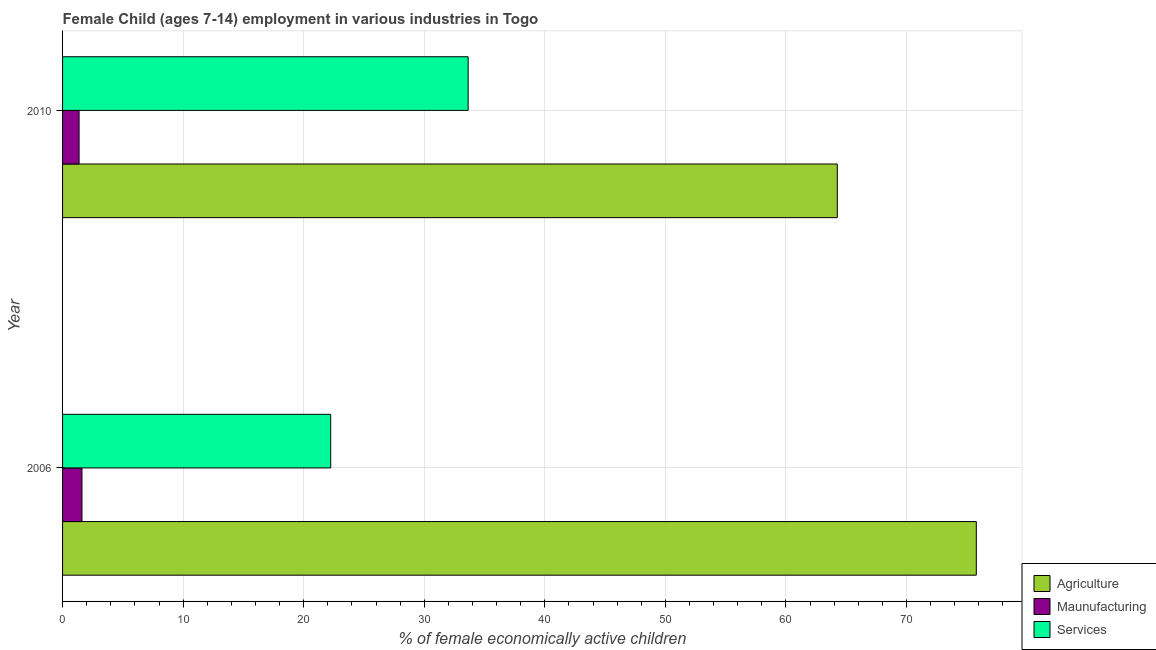How many groups of bars are there?
Keep it short and to the point. 2. How many bars are there on the 2nd tick from the top?
Make the answer very short. 3. What is the percentage of economically active children in services in 2010?
Make the answer very short. 33.64. Across all years, what is the maximum percentage of economically active children in agriculture?
Make the answer very short. 75.79. Across all years, what is the minimum percentage of economically active children in manufacturing?
Keep it short and to the point. 1.37. In which year was the percentage of economically active children in agriculture maximum?
Keep it short and to the point. 2006. In which year was the percentage of economically active children in agriculture minimum?
Make the answer very short. 2010. What is the total percentage of economically active children in services in the graph?
Offer a terse response. 55.88. What is the difference between the percentage of economically active children in services in 2006 and that in 2010?
Your response must be concise. -11.4. What is the difference between the percentage of economically active children in agriculture in 2006 and the percentage of economically active children in manufacturing in 2010?
Make the answer very short. 74.42. What is the average percentage of economically active children in services per year?
Offer a terse response. 27.94. In the year 2010, what is the difference between the percentage of economically active children in services and percentage of economically active children in agriculture?
Keep it short and to the point. -30.62. What is the ratio of the percentage of economically active children in services in 2006 to that in 2010?
Offer a very short reply. 0.66. Is the percentage of economically active children in services in 2006 less than that in 2010?
Offer a very short reply. Yes. In how many years, is the percentage of economically active children in agriculture greater than the average percentage of economically active children in agriculture taken over all years?
Keep it short and to the point. 1. What does the 1st bar from the top in 2006 represents?
Give a very brief answer. Services. What does the 2nd bar from the bottom in 2010 represents?
Give a very brief answer. Maunufacturing. Is it the case that in every year, the sum of the percentage of economically active children in agriculture and percentage of economically active children in manufacturing is greater than the percentage of economically active children in services?
Give a very brief answer. Yes. How many years are there in the graph?
Make the answer very short. 2. What is the difference between two consecutive major ticks on the X-axis?
Offer a terse response. 10. Are the values on the major ticks of X-axis written in scientific E-notation?
Make the answer very short. No. Does the graph contain any zero values?
Your answer should be very brief. No. Does the graph contain grids?
Provide a succinct answer. Yes. What is the title of the graph?
Keep it short and to the point. Female Child (ages 7-14) employment in various industries in Togo. What is the label or title of the X-axis?
Make the answer very short. % of female economically active children. What is the label or title of the Y-axis?
Your answer should be compact. Year. What is the % of female economically active children in Agriculture in 2006?
Provide a succinct answer. 75.79. What is the % of female economically active children in Maunufacturing in 2006?
Provide a succinct answer. 1.61. What is the % of female economically active children in Services in 2006?
Provide a short and direct response. 22.24. What is the % of female economically active children in Agriculture in 2010?
Offer a terse response. 64.26. What is the % of female economically active children of Maunufacturing in 2010?
Offer a very short reply. 1.37. What is the % of female economically active children in Services in 2010?
Provide a short and direct response. 33.64. Across all years, what is the maximum % of female economically active children of Agriculture?
Offer a terse response. 75.79. Across all years, what is the maximum % of female economically active children of Maunufacturing?
Your response must be concise. 1.61. Across all years, what is the maximum % of female economically active children in Services?
Provide a succinct answer. 33.64. Across all years, what is the minimum % of female economically active children in Agriculture?
Provide a succinct answer. 64.26. Across all years, what is the minimum % of female economically active children in Maunufacturing?
Provide a succinct answer. 1.37. Across all years, what is the minimum % of female economically active children of Services?
Make the answer very short. 22.24. What is the total % of female economically active children of Agriculture in the graph?
Provide a short and direct response. 140.05. What is the total % of female economically active children in Maunufacturing in the graph?
Provide a short and direct response. 2.98. What is the total % of female economically active children of Services in the graph?
Offer a very short reply. 55.88. What is the difference between the % of female economically active children of Agriculture in 2006 and that in 2010?
Keep it short and to the point. 11.53. What is the difference between the % of female economically active children in Maunufacturing in 2006 and that in 2010?
Keep it short and to the point. 0.24. What is the difference between the % of female economically active children in Services in 2006 and that in 2010?
Make the answer very short. -11.4. What is the difference between the % of female economically active children of Agriculture in 2006 and the % of female economically active children of Maunufacturing in 2010?
Your answer should be very brief. 74.42. What is the difference between the % of female economically active children in Agriculture in 2006 and the % of female economically active children in Services in 2010?
Offer a terse response. 42.15. What is the difference between the % of female economically active children of Maunufacturing in 2006 and the % of female economically active children of Services in 2010?
Provide a short and direct response. -32.03. What is the average % of female economically active children of Agriculture per year?
Your answer should be compact. 70.03. What is the average % of female economically active children in Maunufacturing per year?
Provide a succinct answer. 1.49. What is the average % of female economically active children of Services per year?
Your answer should be very brief. 27.94. In the year 2006, what is the difference between the % of female economically active children in Agriculture and % of female economically active children in Maunufacturing?
Give a very brief answer. 74.18. In the year 2006, what is the difference between the % of female economically active children of Agriculture and % of female economically active children of Services?
Provide a succinct answer. 53.55. In the year 2006, what is the difference between the % of female economically active children in Maunufacturing and % of female economically active children in Services?
Offer a terse response. -20.63. In the year 2010, what is the difference between the % of female economically active children of Agriculture and % of female economically active children of Maunufacturing?
Offer a terse response. 62.89. In the year 2010, what is the difference between the % of female economically active children of Agriculture and % of female economically active children of Services?
Keep it short and to the point. 30.62. In the year 2010, what is the difference between the % of female economically active children in Maunufacturing and % of female economically active children in Services?
Provide a succinct answer. -32.27. What is the ratio of the % of female economically active children of Agriculture in 2006 to that in 2010?
Your answer should be very brief. 1.18. What is the ratio of the % of female economically active children in Maunufacturing in 2006 to that in 2010?
Make the answer very short. 1.18. What is the ratio of the % of female economically active children in Services in 2006 to that in 2010?
Provide a short and direct response. 0.66. What is the difference between the highest and the second highest % of female economically active children in Agriculture?
Ensure brevity in your answer.  11.53. What is the difference between the highest and the second highest % of female economically active children in Maunufacturing?
Offer a very short reply. 0.24. What is the difference between the highest and the lowest % of female economically active children in Agriculture?
Ensure brevity in your answer.  11.53. What is the difference between the highest and the lowest % of female economically active children in Maunufacturing?
Provide a short and direct response. 0.24. 